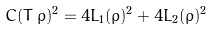Convert formula to latex. <formula><loc_0><loc_0><loc_500><loc_500>C ( T \, \rho ) ^ { 2 } = 4 L _ { 1 } ( \rho ) ^ { 2 } + 4 L _ { 2 } ( \rho ) ^ { 2 }</formula> 